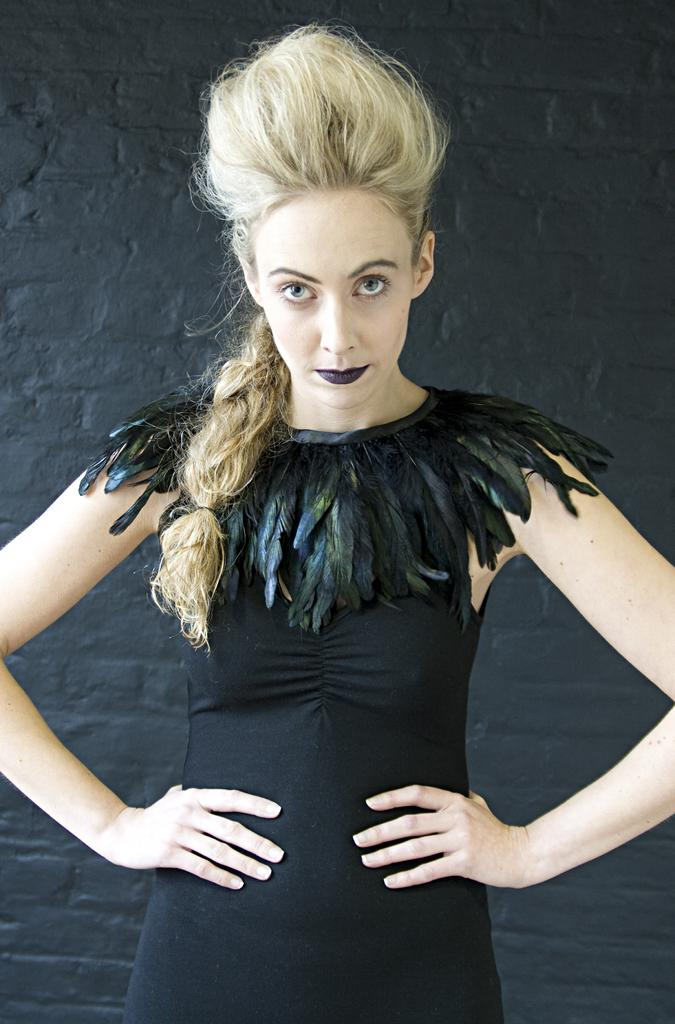What is the main subject of the image? The main subject of the image is a woman. What is the woman wearing in the image? The woman is wearing a black dress in the image. How is the woman described in the image? The woman is described as stunning in the image. What can be seen in the background of the image? There is a wall in the background of the image. What type of canvas is the woman painting in the image? There is no canvas present in the image, and the woman is not depicted as painting. Can you tell me how many yaks are visible in the image? There are no yaks present in the image. 